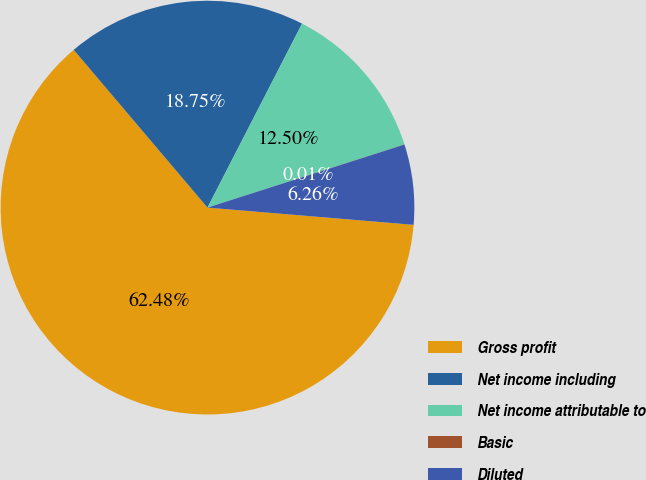Convert chart to OTSL. <chart><loc_0><loc_0><loc_500><loc_500><pie_chart><fcel>Gross profit<fcel>Net income including<fcel>Net income attributable to<fcel>Basic<fcel>Diluted<nl><fcel>62.48%<fcel>18.75%<fcel>12.5%<fcel>0.01%<fcel>6.26%<nl></chart> 